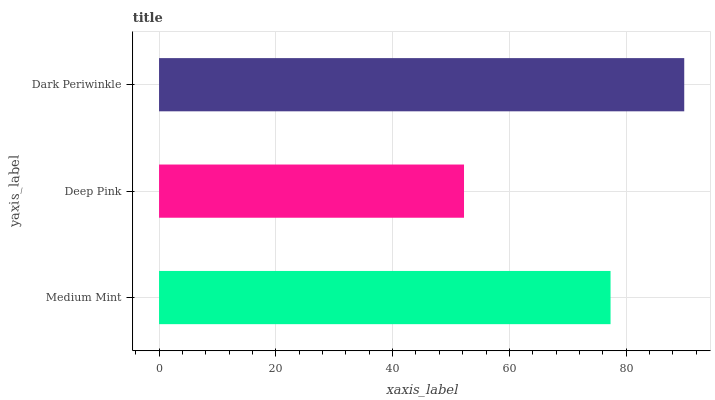Is Deep Pink the minimum?
Answer yes or no. Yes. Is Dark Periwinkle the maximum?
Answer yes or no. Yes. Is Dark Periwinkle the minimum?
Answer yes or no. No. Is Deep Pink the maximum?
Answer yes or no. No. Is Dark Periwinkle greater than Deep Pink?
Answer yes or no. Yes. Is Deep Pink less than Dark Periwinkle?
Answer yes or no. Yes. Is Deep Pink greater than Dark Periwinkle?
Answer yes or no. No. Is Dark Periwinkle less than Deep Pink?
Answer yes or no. No. Is Medium Mint the high median?
Answer yes or no. Yes. Is Medium Mint the low median?
Answer yes or no. Yes. Is Dark Periwinkle the high median?
Answer yes or no. No. Is Dark Periwinkle the low median?
Answer yes or no. No. 